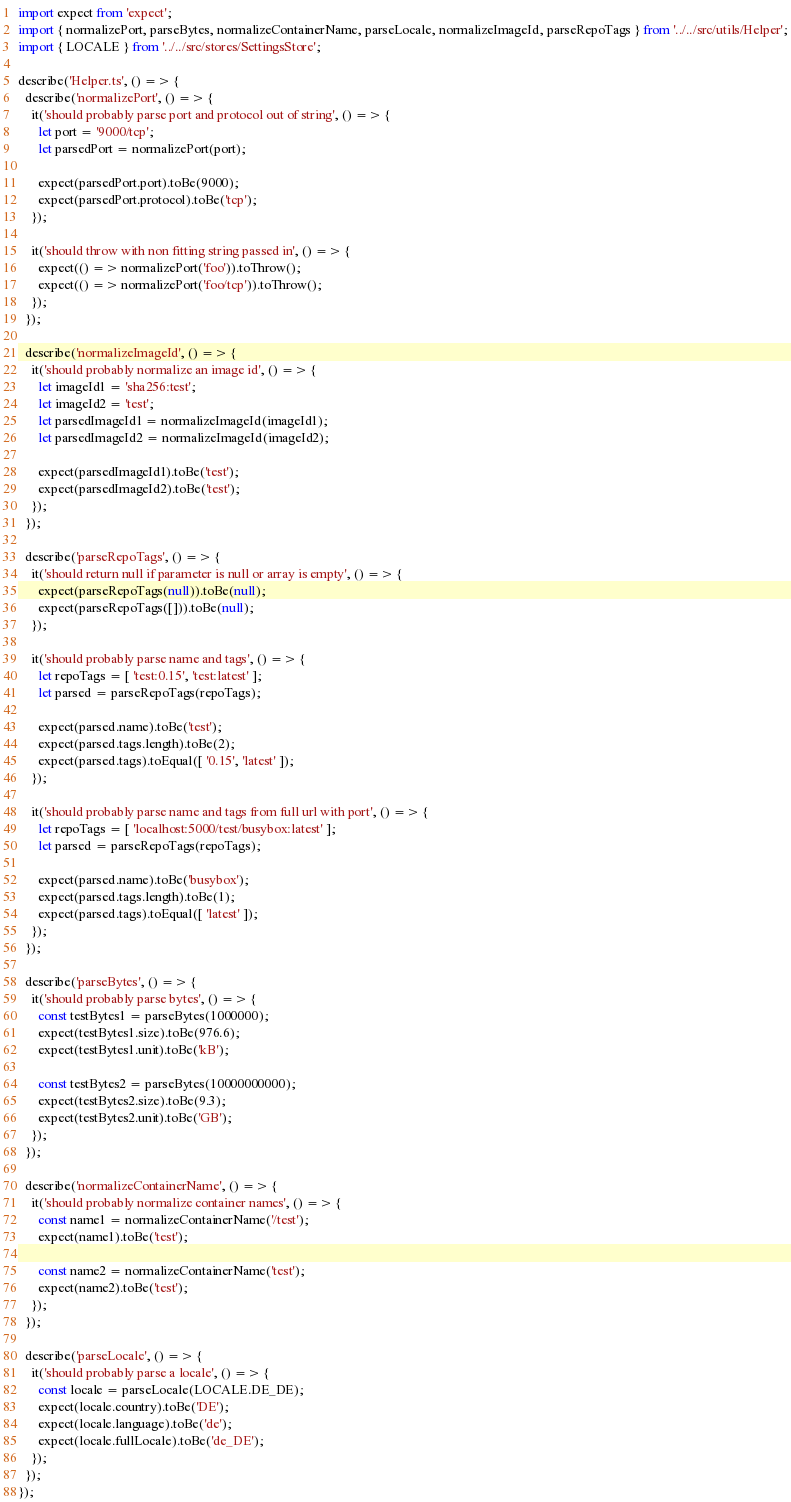<code> <loc_0><loc_0><loc_500><loc_500><_TypeScript_>import expect from 'expect';
import { normalizePort, parseBytes, normalizeContainerName, parseLocale, normalizeImageId, parseRepoTags } from '../../src/utils/Helper';
import { LOCALE } from '../../src/stores/SettingsStore';

describe('Helper.ts', () => {
  describe('normalizePort', () => {
    it('should probably parse port and protocol out of string', () => {
      let port = '9000/tcp';
      let parsedPort = normalizePort(port);

      expect(parsedPort.port).toBe(9000);
      expect(parsedPort.protocol).toBe('tcp');
    });

    it('should throw with non fitting string passed in', () => {
      expect(() => normalizePort('foo')).toThrow();
      expect(() => normalizePort('foo/tcp')).toThrow();
    });
  });

  describe('normalizeImageId', () => {
    it('should probably normalize an image id', () => {
      let imageId1 = 'sha256:test';
      let imageId2 = 'test';
      let parsedImageId1 = normalizeImageId(imageId1);
      let parsedImageId2 = normalizeImageId(imageId2);

      expect(parsedImageId1).toBe('test');
      expect(parsedImageId2).toBe('test');
    });
  });

  describe('parseRepoTags', () => {
    it('should return null if parameter is null or array is empty', () => {
      expect(parseRepoTags(null)).toBe(null);
      expect(parseRepoTags([])).toBe(null);
    });

    it('should probably parse name and tags', () => {
      let repoTags = [ 'test:0.15', 'test:latest' ];
      let parsed = parseRepoTags(repoTags);

      expect(parsed.name).toBe('test');
      expect(parsed.tags.length).toBe(2);
      expect(parsed.tags).toEqual([ '0.15', 'latest' ]);
    });

    it('should probably parse name and tags from full url with port', () => {
      let repoTags = [ 'localhost:5000/test/busybox:latest' ];
      let parsed = parseRepoTags(repoTags);

      expect(parsed.name).toBe('busybox');
      expect(parsed.tags.length).toBe(1);
      expect(parsed.tags).toEqual([ 'latest' ]);
    });
  });

  describe('parseBytes', () => {
    it('should probably parse bytes', () => {
      const testBytes1 = parseBytes(1000000);
      expect(testBytes1.size).toBe(976.6);
      expect(testBytes1.unit).toBe('kB');

      const testBytes2 = parseBytes(10000000000);
      expect(testBytes2.size).toBe(9.3);
      expect(testBytes2.unit).toBe('GB');
    });
  });

  describe('normalizeContainerName', () => {
    it('should probably normalize container names', () => {
      const name1 = normalizeContainerName('/test');
      expect(name1).toBe('test');

      const name2 = normalizeContainerName('test');
      expect(name2).toBe('test');
    });
  });

  describe('parseLocale', () => {
    it('should probably parse a locale', () => {
      const locale = parseLocale(LOCALE.DE_DE);
      expect(locale.country).toBe('DE');
      expect(locale.language).toBe('de');
      expect(locale.fullLocale).toBe('de_DE');
    });
  });
});
</code> 